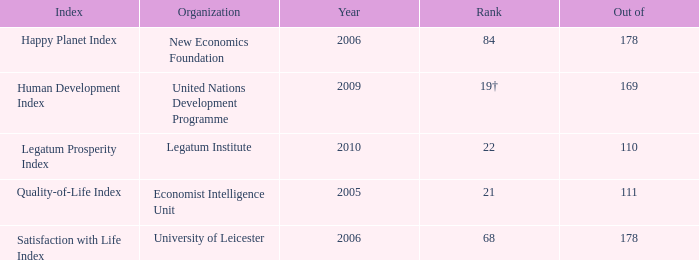What organization ranks 68? University of Leicester. 